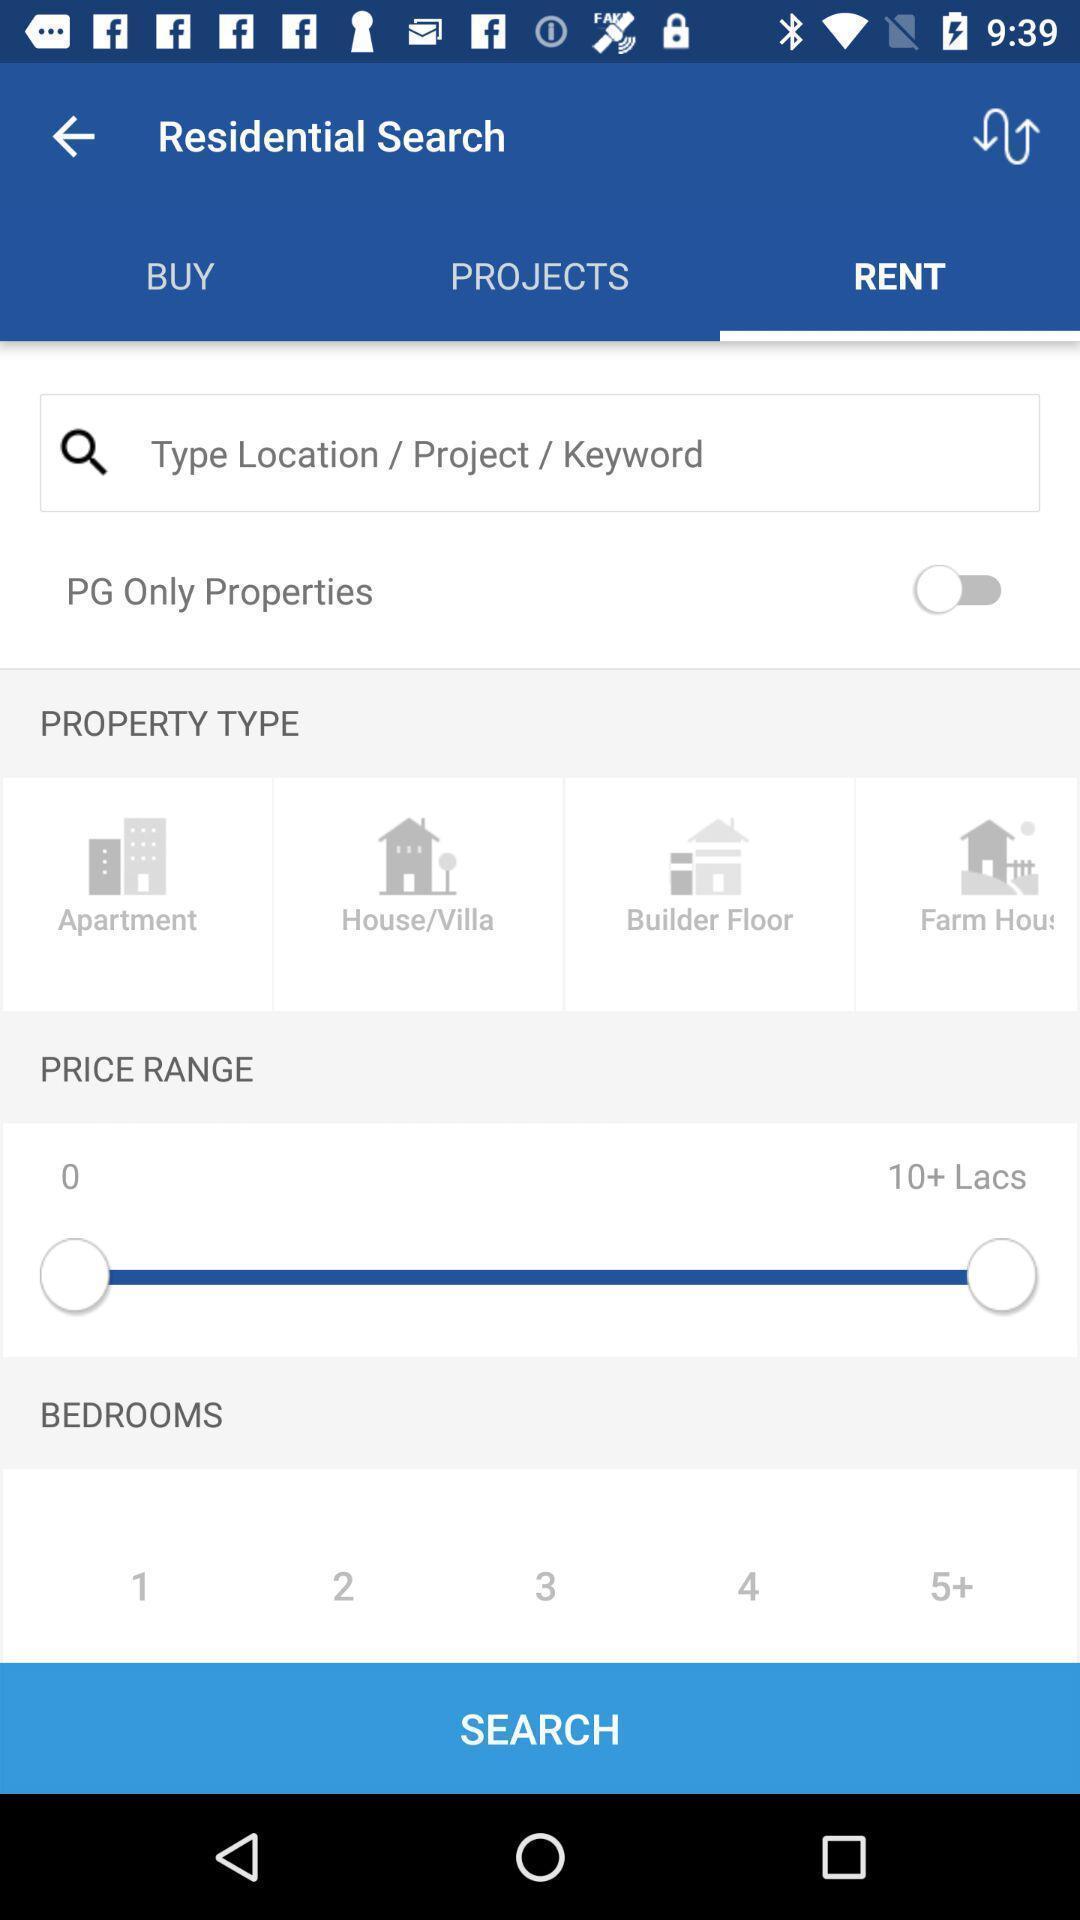What details can you identify in this image? Page showing multiple categories in app. 